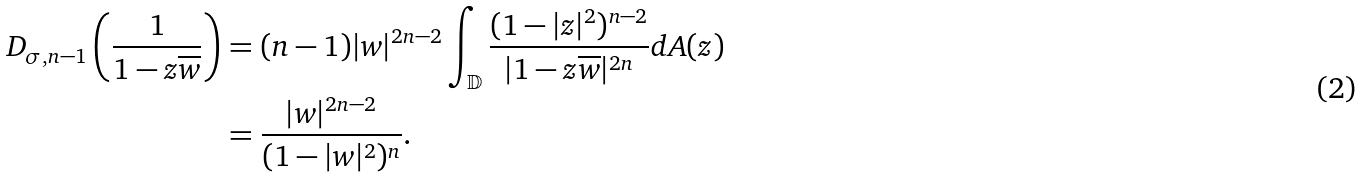<formula> <loc_0><loc_0><loc_500><loc_500>D _ { \sigma , n - 1 } \left ( \frac { 1 } { 1 - z \overline { w } } \right ) & = ( n - 1 ) | w | ^ { 2 n - 2 } \int _ { \mathbb { D } } \frac { ( 1 - | z | ^ { 2 } ) ^ { n - 2 } } { | 1 - z \overline { w } | ^ { 2 n } } d A ( z ) \\ & = \frac { | w | ^ { 2 n - 2 } } { ( 1 - | w | ^ { 2 } ) ^ { n } } .</formula> 